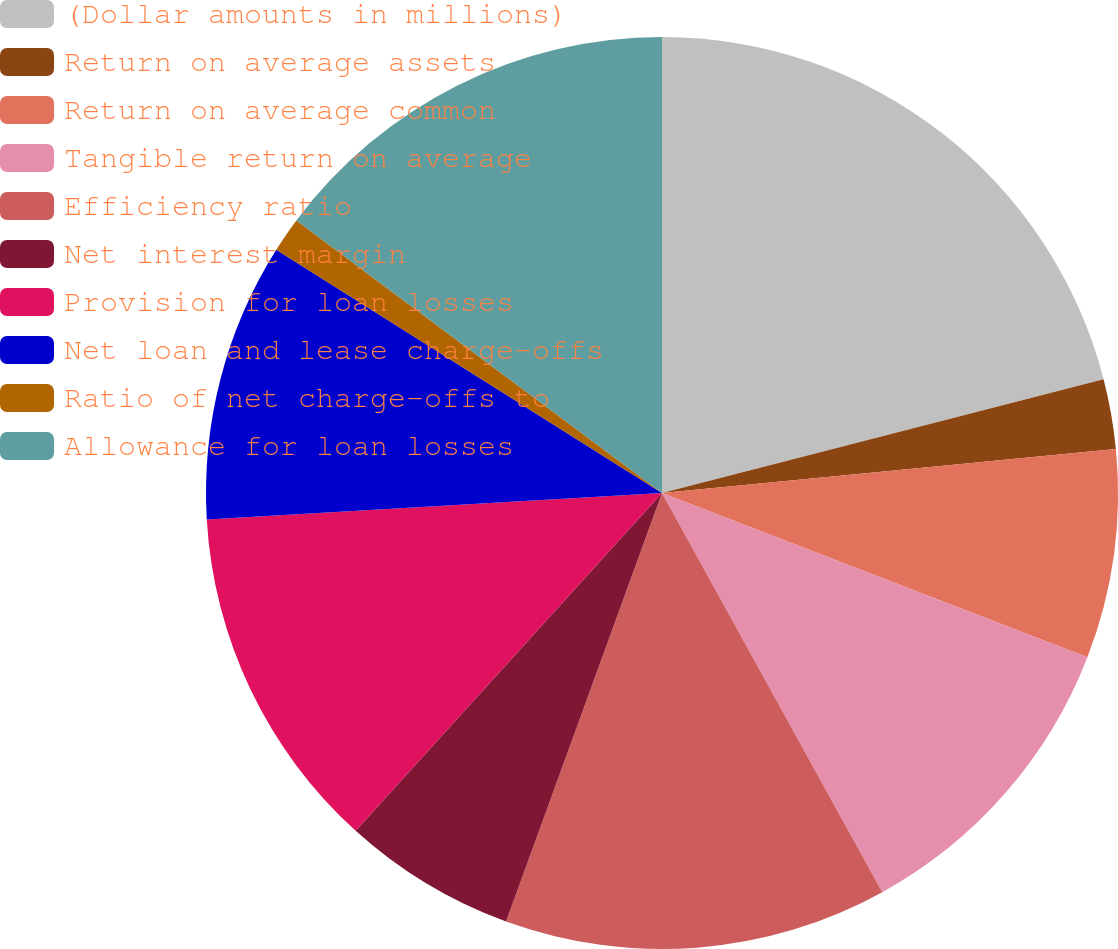Convert chart to OTSL. <chart><loc_0><loc_0><loc_500><loc_500><pie_chart><fcel>(Dollar amounts in millions)<fcel>Return on average assets<fcel>Return on average common<fcel>Tangible return on average<fcel>Efficiency ratio<fcel>Net interest margin<fcel>Provision for loan losses<fcel>Net loan and lease charge-offs<fcel>Ratio of net charge-offs to<fcel>Allowance for loan losses<nl><fcel>20.99%<fcel>2.47%<fcel>7.41%<fcel>11.11%<fcel>13.58%<fcel>6.17%<fcel>12.35%<fcel>9.88%<fcel>1.24%<fcel>14.81%<nl></chart> 